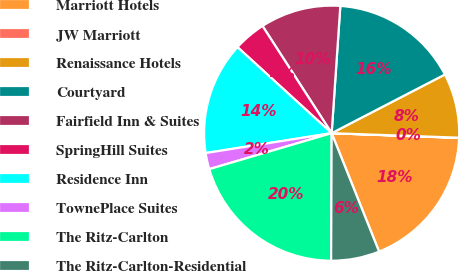Convert chart to OTSL. <chart><loc_0><loc_0><loc_500><loc_500><pie_chart><fcel>Marriott Hotels<fcel>JW Marriott<fcel>Renaissance Hotels<fcel>Courtyard<fcel>Fairfield Inn & Suites<fcel>SpringHill Suites<fcel>Residence Inn<fcel>TownePlace Suites<fcel>The Ritz-Carlton<fcel>The Ritz-Carlton-Residential<nl><fcel>18.34%<fcel>0.03%<fcel>8.17%<fcel>16.31%<fcel>10.2%<fcel>4.1%<fcel>14.27%<fcel>2.06%<fcel>20.38%<fcel>6.13%<nl></chart> 